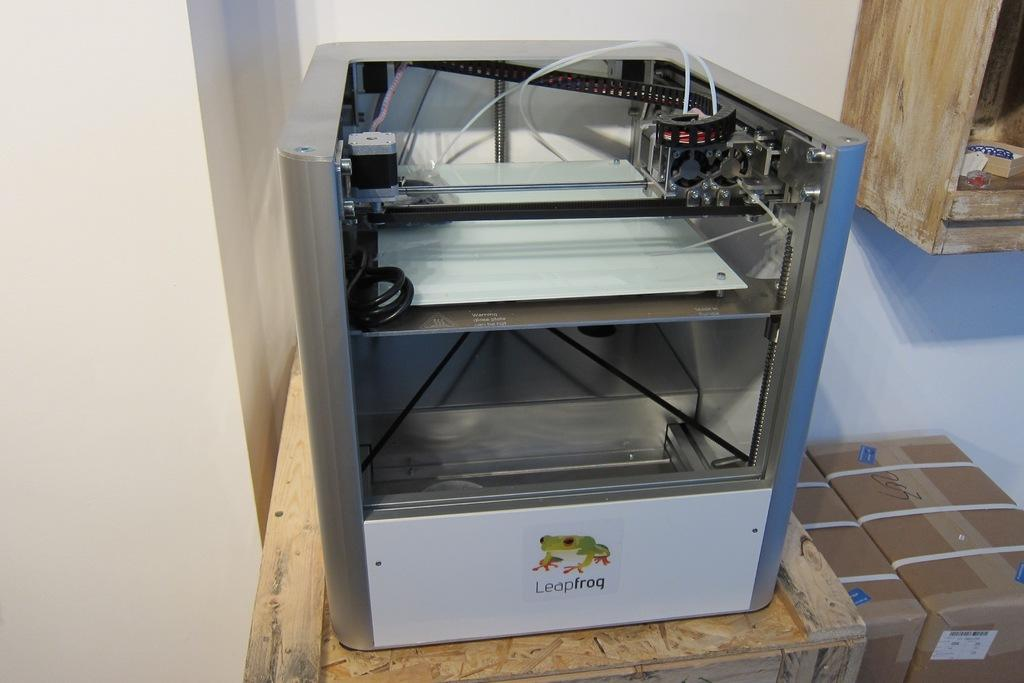<image>
Share a concise interpretation of the image provided. The leap frog logo has a green tree frog on it. 